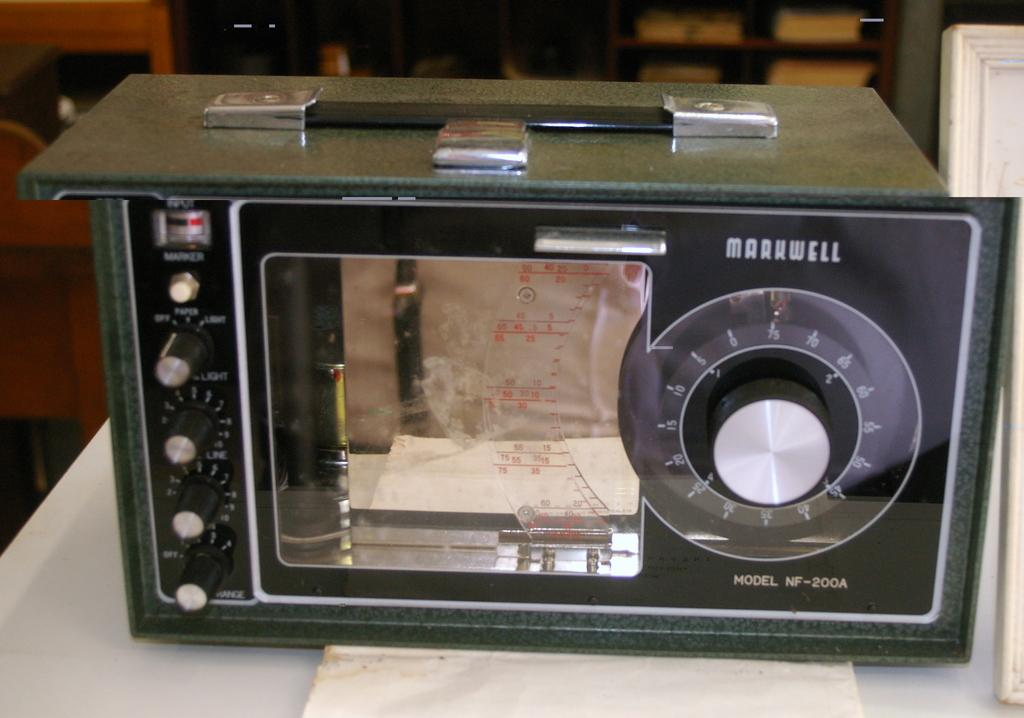What type of object can be seen in the image that resembles a radio? There is a radio-like object in the image. What story is being told in the caption of the image? There is no caption present in the image, so no story can be told. 